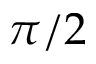<formula> <loc_0><loc_0><loc_500><loc_500>\pi / 2</formula> 